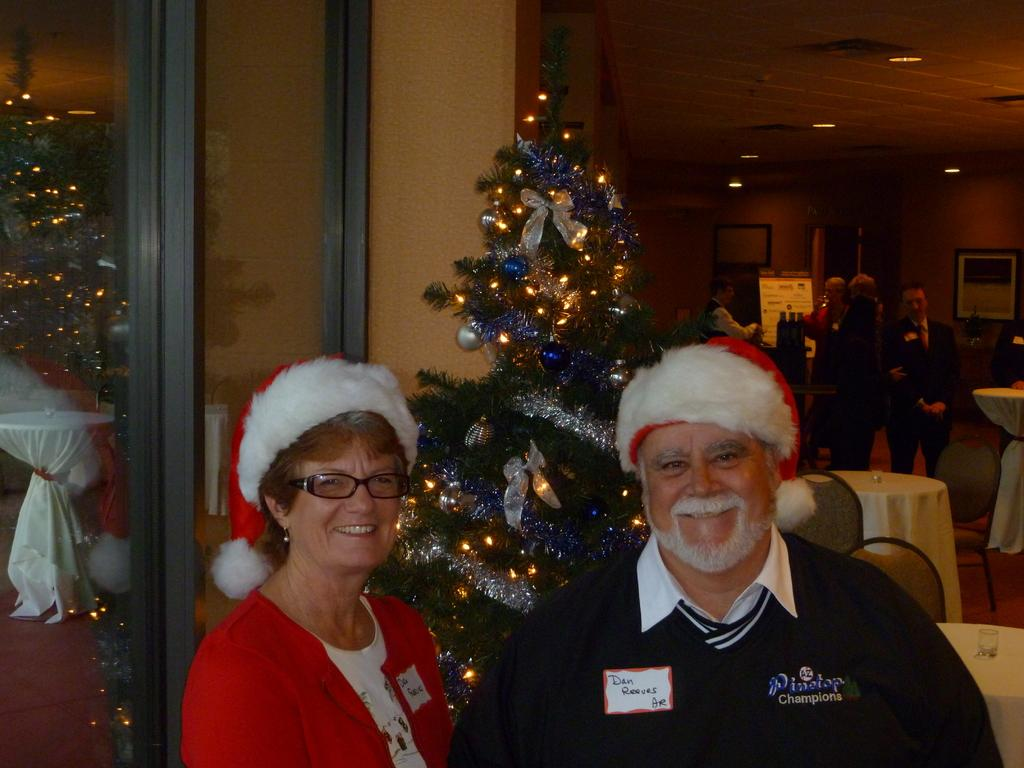<image>
Provide a brief description of the given image. Dan Reeves poses in a Santa hat next to a lady also wearing a Santa hat. 